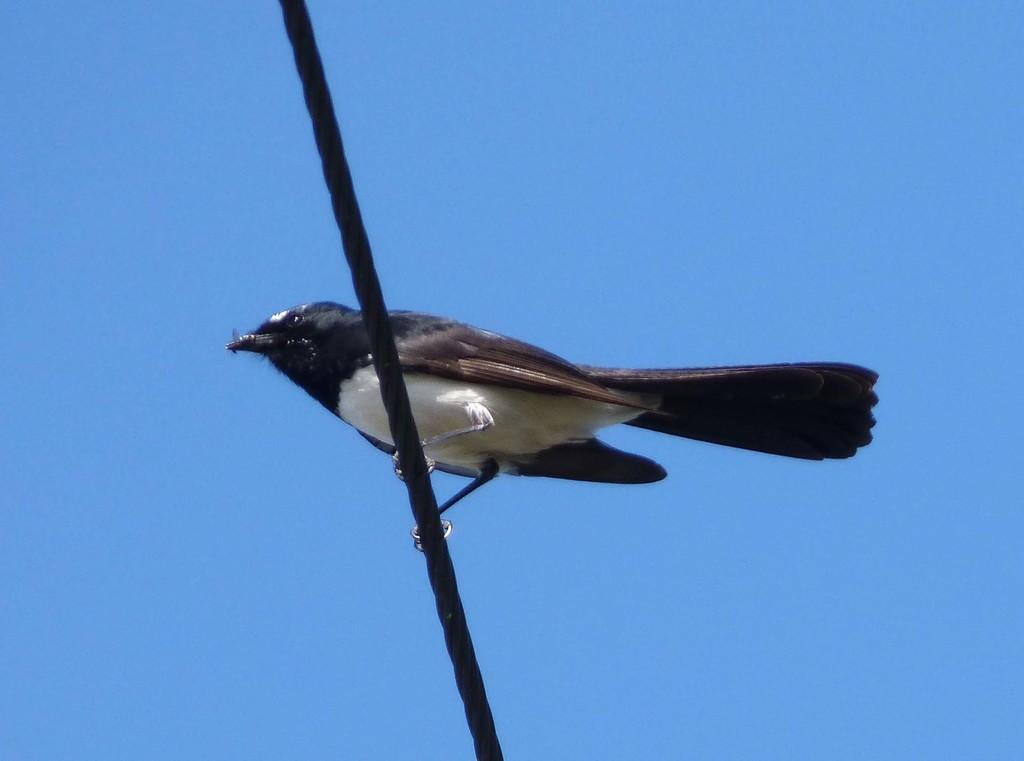What type of animal can be seen in the image? There is a bird in the image. What is the bird standing on? The bird is standing on a rope. Where is the rope located in the image? The rope is in the middle of the image. What can be seen in the background of the image? There is the sky visible in the background of the image. What type of bath can be seen in the image? There is no bath present in the image; it features a bird standing on a rope. 